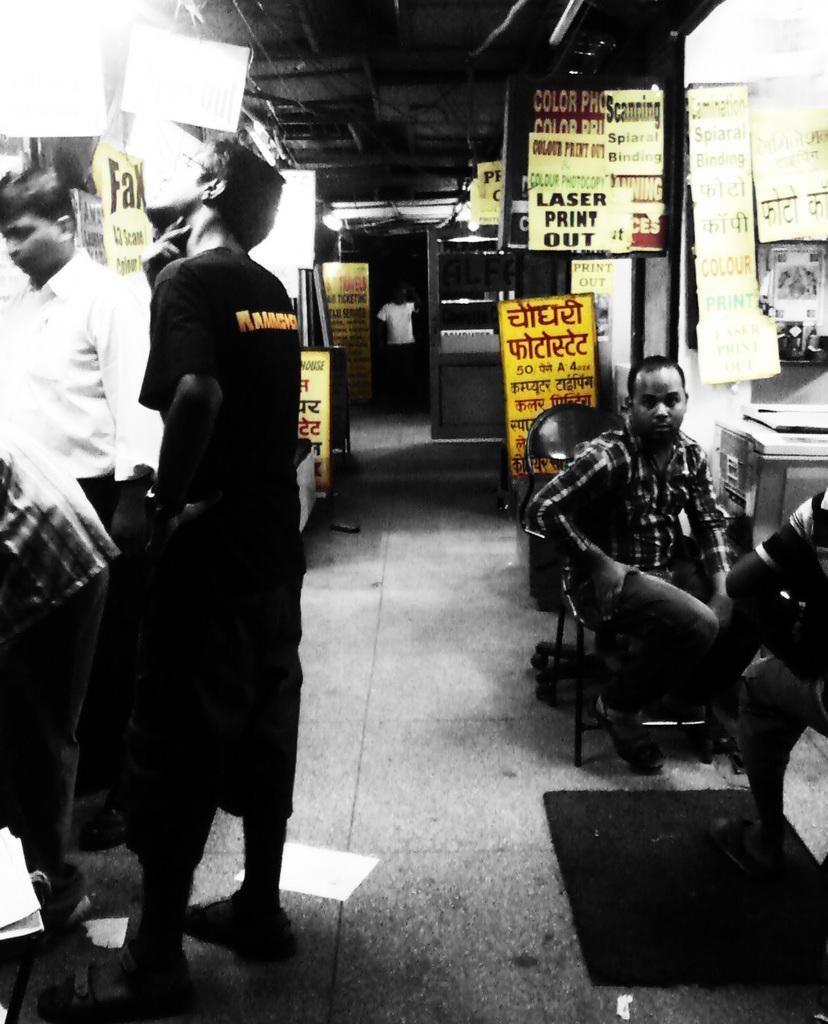Can you describe this image briefly? On the right side of the image there are two persons sitting on the chairs. Behind them there is an object. On the left side of the image there are three people standing on the floor. In the background of the image there are display boards and lights. At the bottom of the image there is a mat on the floor. 